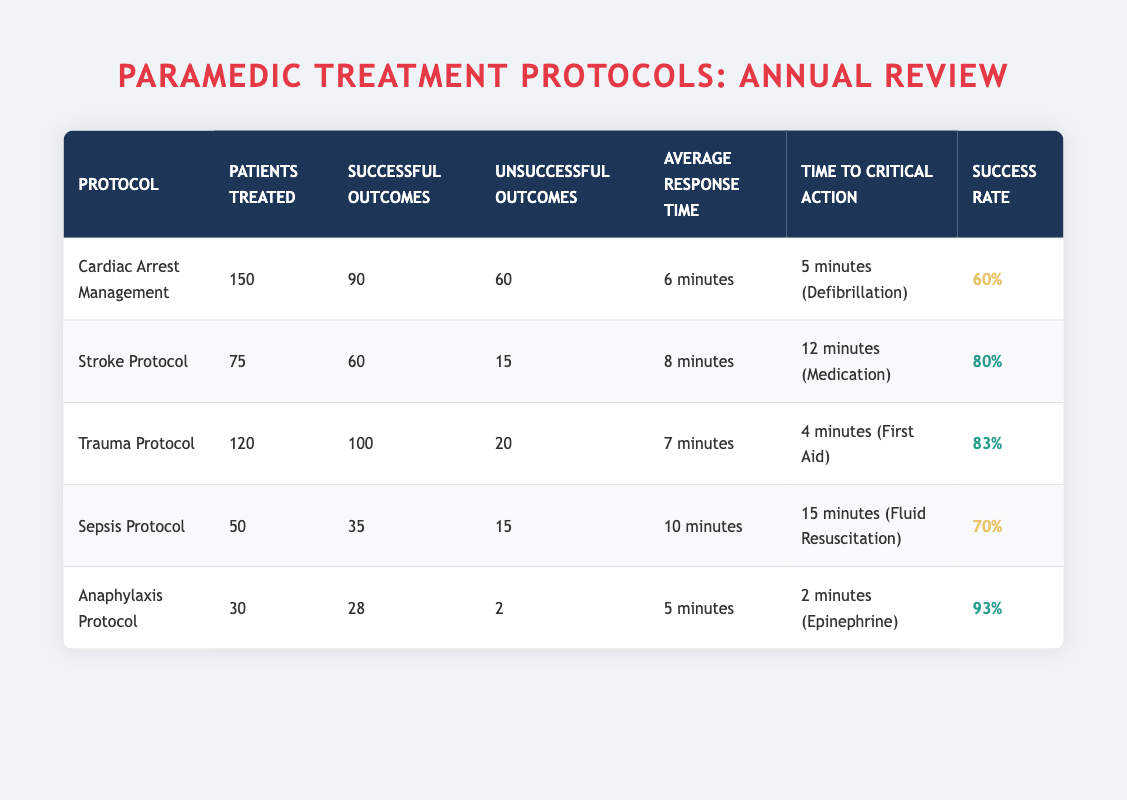What is the success rate of the Stroke Protocol? The success rate for the Stroke Protocol is listed in the "Success Rate" column as 80%.
Answer: 80% How many patients were treated under the Anaphylaxis Protocol? The number of patients treated under the Anaphylaxis Protocol is provided in the "Patients Treated" column as 30.
Answer: 30 Which protocol has the lowest success rate? Comparing the success rates of all protocols, the Cardiac Arrest Management has the lowest rate at 60% when looking at the "Success Rate" column.
Answer: Cardiac Arrest Management What is the average response time across all protocols? To find the average response time, we take the total response times (6 + 8 + 7 + 10 + 5) = 36 minutes and divide that by the number of protocols (5). The average response time is 36/5 = 7.2 minutes.
Answer: 7.2 minutes Is the Trauma Protocol successful for more than 80 patients treated? Yes, the Trauma Protocol treated 120 patients and had 100 successful outcomes. The total treated patients is more than 80.
Answer: Yes What is the total number of unsuccessful outcomes from all protocols? By adding the unsuccessful outcomes from each protocol: (60 + 15 + 20 + 15 + 2) = 112. The total number of unsuccessful outcomes is 112.
Answer: 112 Which protocol had the quickest time to critical action? The Anaphylaxis Protocol shows the quickest time to critical action in the "Time to Critical Action" column, which is 2 minutes for administering epinephrine.
Answer: Anaphylaxis Protocol How many more successful outcomes did the Trauma Protocol have compared to the Sepsis Protocol? The Trauma Protocol had 100 successful outcomes, while the Sepsis Protocol had 35. The difference is 100 - 35 = 65 more successful outcomes.
Answer: 65 What percentage of patients treated under the Sepsis Protocol had unsuccessful outcomes? For the Sepsis Protocol, there were 15 unsuccessful outcomes out of 50 patients treated. The percentage is (15/50) * 100 = 30%.
Answer: 30% 